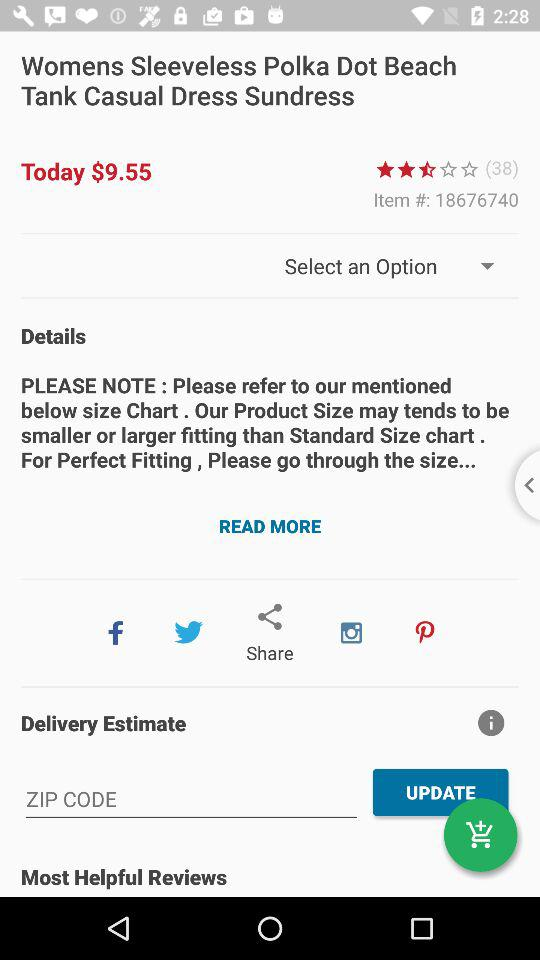What is the rating? The rating is 2.5 stars. 